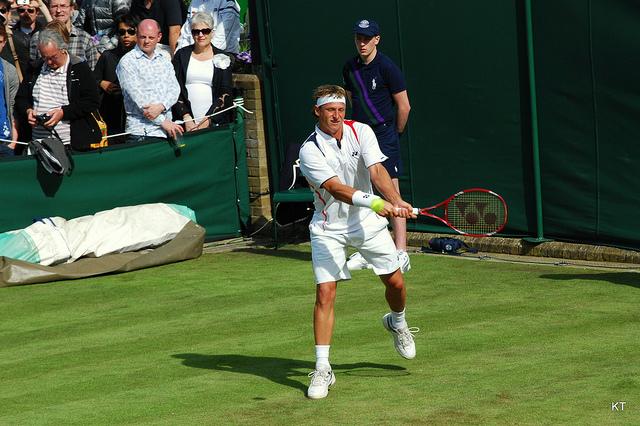Is this court grass?
Quick response, please. Yes. What color is the ball?
Concise answer only. Yellow. Which country is Wimbledon in?
Concise answer only. England. What gender is the person in the background front row that's wearing sunglasses?
Answer briefly. Female. What number is on the man's white shorts?
Answer briefly. 1. Is one of the man balding?
Be succinct. Yes. What is the main color of his tennis racket?
Be succinct. Red. 